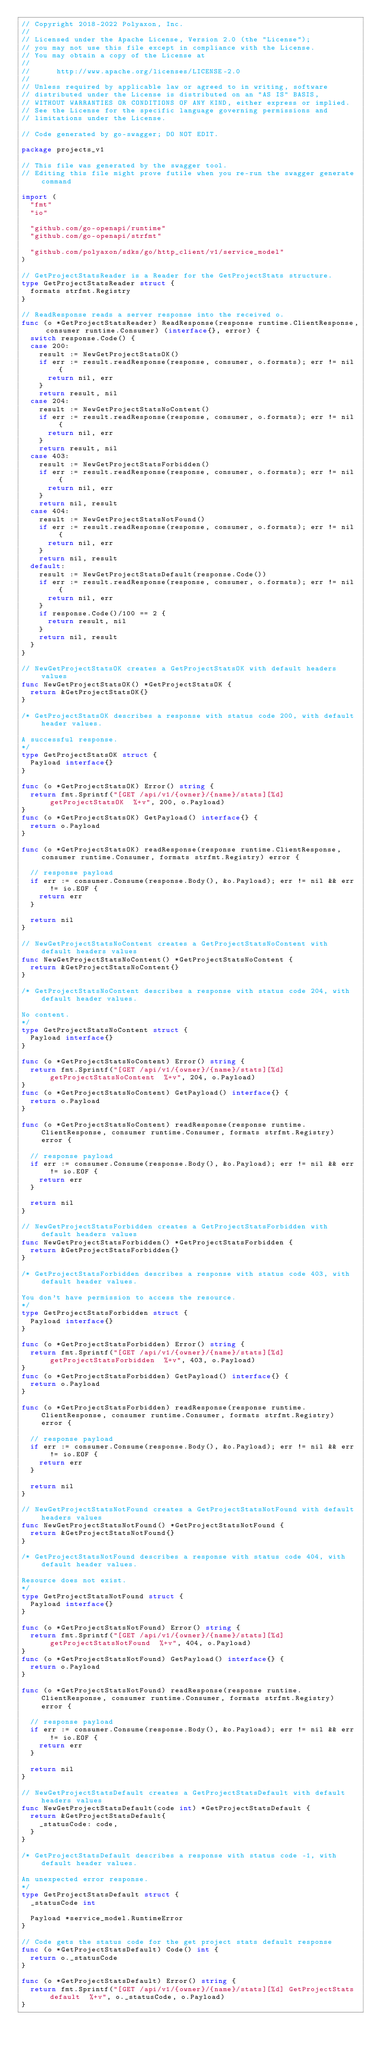<code> <loc_0><loc_0><loc_500><loc_500><_Go_>// Copyright 2018-2022 Polyaxon, Inc.
//
// Licensed under the Apache License, Version 2.0 (the "License");
// you may not use this file except in compliance with the License.
// You may obtain a copy of the License at
//
//      http://www.apache.org/licenses/LICENSE-2.0
//
// Unless required by applicable law or agreed to in writing, software
// distributed under the License is distributed on an "AS IS" BASIS,
// WITHOUT WARRANTIES OR CONDITIONS OF ANY KIND, either express or implied.
// See the License for the specific language governing permissions and
// limitations under the License.

// Code generated by go-swagger; DO NOT EDIT.

package projects_v1

// This file was generated by the swagger tool.
// Editing this file might prove futile when you re-run the swagger generate command

import (
	"fmt"
	"io"

	"github.com/go-openapi/runtime"
	"github.com/go-openapi/strfmt"

	"github.com/polyaxon/sdks/go/http_client/v1/service_model"
)

// GetProjectStatsReader is a Reader for the GetProjectStats structure.
type GetProjectStatsReader struct {
	formats strfmt.Registry
}

// ReadResponse reads a server response into the received o.
func (o *GetProjectStatsReader) ReadResponse(response runtime.ClientResponse, consumer runtime.Consumer) (interface{}, error) {
	switch response.Code() {
	case 200:
		result := NewGetProjectStatsOK()
		if err := result.readResponse(response, consumer, o.formats); err != nil {
			return nil, err
		}
		return result, nil
	case 204:
		result := NewGetProjectStatsNoContent()
		if err := result.readResponse(response, consumer, o.formats); err != nil {
			return nil, err
		}
		return result, nil
	case 403:
		result := NewGetProjectStatsForbidden()
		if err := result.readResponse(response, consumer, o.formats); err != nil {
			return nil, err
		}
		return nil, result
	case 404:
		result := NewGetProjectStatsNotFound()
		if err := result.readResponse(response, consumer, o.formats); err != nil {
			return nil, err
		}
		return nil, result
	default:
		result := NewGetProjectStatsDefault(response.Code())
		if err := result.readResponse(response, consumer, o.formats); err != nil {
			return nil, err
		}
		if response.Code()/100 == 2 {
			return result, nil
		}
		return nil, result
	}
}

// NewGetProjectStatsOK creates a GetProjectStatsOK with default headers values
func NewGetProjectStatsOK() *GetProjectStatsOK {
	return &GetProjectStatsOK{}
}

/* GetProjectStatsOK describes a response with status code 200, with default header values.

A successful response.
*/
type GetProjectStatsOK struct {
	Payload interface{}
}

func (o *GetProjectStatsOK) Error() string {
	return fmt.Sprintf("[GET /api/v1/{owner}/{name}/stats][%d] getProjectStatsOK  %+v", 200, o.Payload)
}
func (o *GetProjectStatsOK) GetPayload() interface{} {
	return o.Payload
}

func (o *GetProjectStatsOK) readResponse(response runtime.ClientResponse, consumer runtime.Consumer, formats strfmt.Registry) error {

	// response payload
	if err := consumer.Consume(response.Body(), &o.Payload); err != nil && err != io.EOF {
		return err
	}

	return nil
}

// NewGetProjectStatsNoContent creates a GetProjectStatsNoContent with default headers values
func NewGetProjectStatsNoContent() *GetProjectStatsNoContent {
	return &GetProjectStatsNoContent{}
}

/* GetProjectStatsNoContent describes a response with status code 204, with default header values.

No content.
*/
type GetProjectStatsNoContent struct {
	Payload interface{}
}

func (o *GetProjectStatsNoContent) Error() string {
	return fmt.Sprintf("[GET /api/v1/{owner}/{name}/stats][%d] getProjectStatsNoContent  %+v", 204, o.Payload)
}
func (o *GetProjectStatsNoContent) GetPayload() interface{} {
	return o.Payload
}

func (o *GetProjectStatsNoContent) readResponse(response runtime.ClientResponse, consumer runtime.Consumer, formats strfmt.Registry) error {

	// response payload
	if err := consumer.Consume(response.Body(), &o.Payload); err != nil && err != io.EOF {
		return err
	}

	return nil
}

// NewGetProjectStatsForbidden creates a GetProjectStatsForbidden with default headers values
func NewGetProjectStatsForbidden() *GetProjectStatsForbidden {
	return &GetProjectStatsForbidden{}
}

/* GetProjectStatsForbidden describes a response with status code 403, with default header values.

You don't have permission to access the resource.
*/
type GetProjectStatsForbidden struct {
	Payload interface{}
}

func (o *GetProjectStatsForbidden) Error() string {
	return fmt.Sprintf("[GET /api/v1/{owner}/{name}/stats][%d] getProjectStatsForbidden  %+v", 403, o.Payload)
}
func (o *GetProjectStatsForbidden) GetPayload() interface{} {
	return o.Payload
}

func (o *GetProjectStatsForbidden) readResponse(response runtime.ClientResponse, consumer runtime.Consumer, formats strfmt.Registry) error {

	// response payload
	if err := consumer.Consume(response.Body(), &o.Payload); err != nil && err != io.EOF {
		return err
	}

	return nil
}

// NewGetProjectStatsNotFound creates a GetProjectStatsNotFound with default headers values
func NewGetProjectStatsNotFound() *GetProjectStatsNotFound {
	return &GetProjectStatsNotFound{}
}

/* GetProjectStatsNotFound describes a response with status code 404, with default header values.

Resource does not exist.
*/
type GetProjectStatsNotFound struct {
	Payload interface{}
}

func (o *GetProjectStatsNotFound) Error() string {
	return fmt.Sprintf("[GET /api/v1/{owner}/{name}/stats][%d] getProjectStatsNotFound  %+v", 404, o.Payload)
}
func (o *GetProjectStatsNotFound) GetPayload() interface{} {
	return o.Payload
}

func (o *GetProjectStatsNotFound) readResponse(response runtime.ClientResponse, consumer runtime.Consumer, formats strfmt.Registry) error {

	// response payload
	if err := consumer.Consume(response.Body(), &o.Payload); err != nil && err != io.EOF {
		return err
	}

	return nil
}

// NewGetProjectStatsDefault creates a GetProjectStatsDefault with default headers values
func NewGetProjectStatsDefault(code int) *GetProjectStatsDefault {
	return &GetProjectStatsDefault{
		_statusCode: code,
	}
}

/* GetProjectStatsDefault describes a response with status code -1, with default header values.

An unexpected error response.
*/
type GetProjectStatsDefault struct {
	_statusCode int

	Payload *service_model.RuntimeError
}

// Code gets the status code for the get project stats default response
func (o *GetProjectStatsDefault) Code() int {
	return o._statusCode
}

func (o *GetProjectStatsDefault) Error() string {
	return fmt.Sprintf("[GET /api/v1/{owner}/{name}/stats][%d] GetProjectStats default  %+v", o._statusCode, o.Payload)
}</code> 